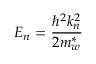<formula> <loc_0><loc_0><loc_500><loc_500>E _ { n } = { \frac { \hbar { ^ } { 2 } k _ { n } ^ { 2 } } { 2 m _ { w } ^ { * } } }</formula> 